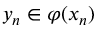<formula> <loc_0><loc_0><loc_500><loc_500>y _ { n } \in \varphi ( x _ { n } )</formula> 